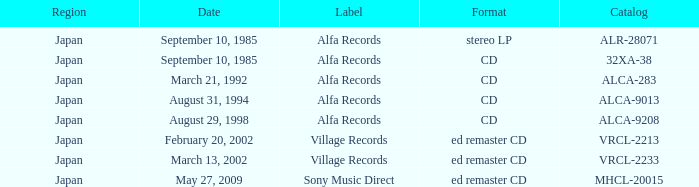Which marking was documented as alca-9013? Alfa Records. 